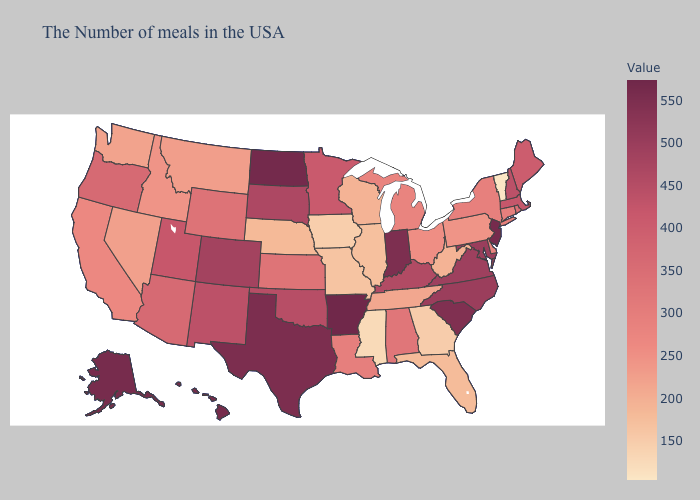Which states have the highest value in the USA?
Answer briefly. Arkansas. Does Maine have the highest value in the Northeast?
Answer briefly. No. Does the map have missing data?
Give a very brief answer. No. Does Tennessee have the lowest value in the South?
Short answer required. No. 